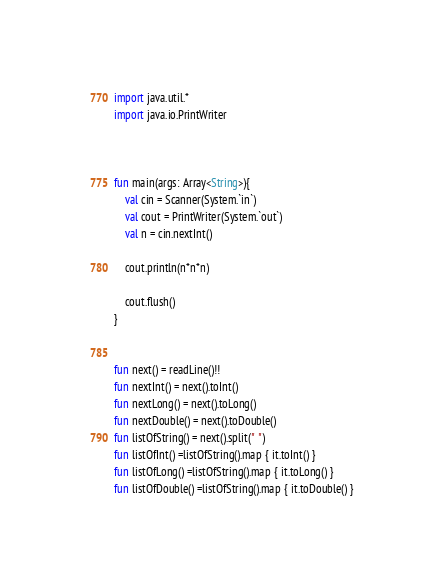<code> <loc_0><loc_0><loc_500><loc_500><_Kotlin_>import java.util.*
import java.io.PrintWriter



fun main(args: Array<String>){
	val cin = Scanner(System.`in`)
    val cout = PrintWriter(System.`out`)
    val n = cin.nextInt()

    cout.println(n*n*n)
    
    cout.flush()
}


fun next() = readLine()!!
fun nextInt() = next().toInt()
fun nextLong() = next().toLong()
fun nextDouble() = next().toDouble()
fun listOfString() = next().split(" ")
fun listOfInt() =listOfString().map { it.toInt() }
fun listOfLong() =listOfString().map { it.toLong() }
fun listOfDouble() =listOfString().map { it.toDouble() }</code> 